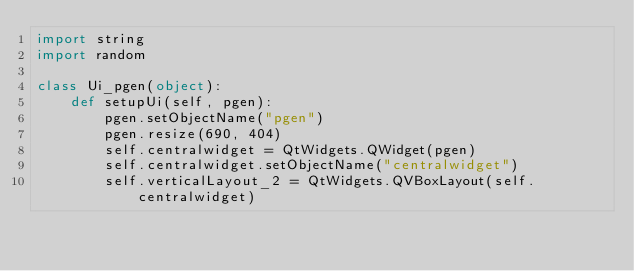Convert code to text. <code><loc_0><loc_0><loc_500><loc_500><_Python_>import string
import random

class Ui_pgen(object):
    def setupUi(self, pgen):
        pgen.setObjectName("pgen")
        pgen.resize(690, 404)
        self.centralwidget = QtWidgets.QWidget(pgen)
        self.centralwidget.setObjectName("centralwidget")
        self.verticalLayout_2 = QtWidgets.QVBoxLayout(self.centralwidget)</code> 